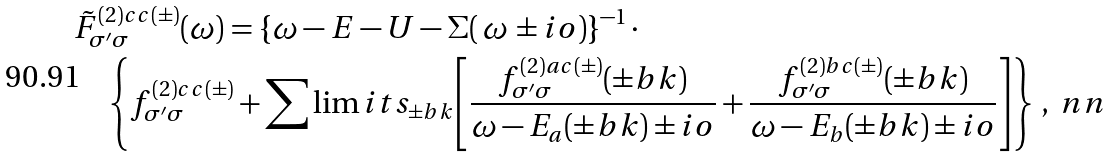<formula> <loc_0><loc_0><loc_500><loc_500>& \tilde { F } _ { { \sigma } ^ { \prime } \sigma } ^ { ( 2 ) c c ( \pm ) } ( \omega ) = \{ \omega - E - U - \Sigma ( \, \omega \, \pm i o ) \} ^ { - 1 } \, \cdot \\ & \quad \left \{ { f _ { { \sigma } ^ { \prime } \sigma } ^ { ( 2 ) c c ( \pm ) } + \sum \lim i t s _ { \pm b k } { \left [ { \frac { f _ { { \sigma } ^ { \prime } \sigma } ^ { ( 2 ) a c ( \pm ) } ( { \pm b k } ) } { \omega - E _ { a } ( { \pm b k } ) \pm i o } + \frac { f _ { { \sigma } ^ { \prime } \sigma } ^ { ( 2 ) b c ( \pm ) } ( { \pm b k } ) } { \omega - E _ { b } ( { \pm b k } ) \pm i o } } \right ] } } \right \} \, , \ n n</formula> 